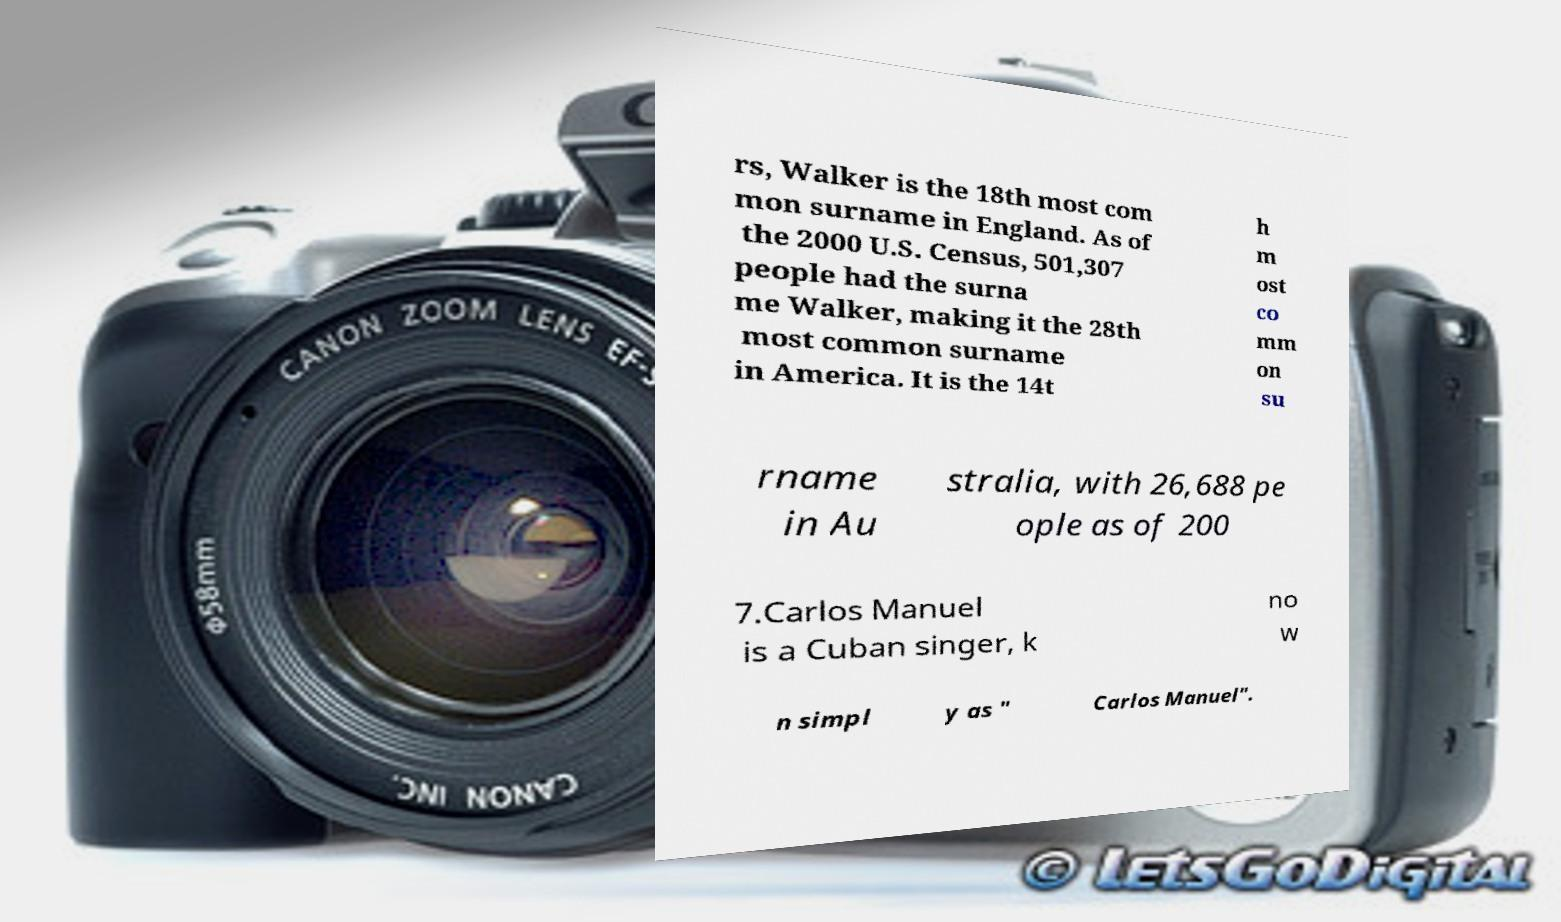For documentation purposes, I need the text within this image transcribed. Could you provide that? rs, Walker is the 18th most com mon surname in England. As of the 2000 U.S. Census, 501,307 people had the surna me Walker, making it the 28th most common surname in America. It is the 14t h m ost co mm on su rname in Au stralia, with 26,688 pe ople as of 200 7.Carlos Manuel is a Cuban singer, k no w n simpl y as " Carlos Manuel". 